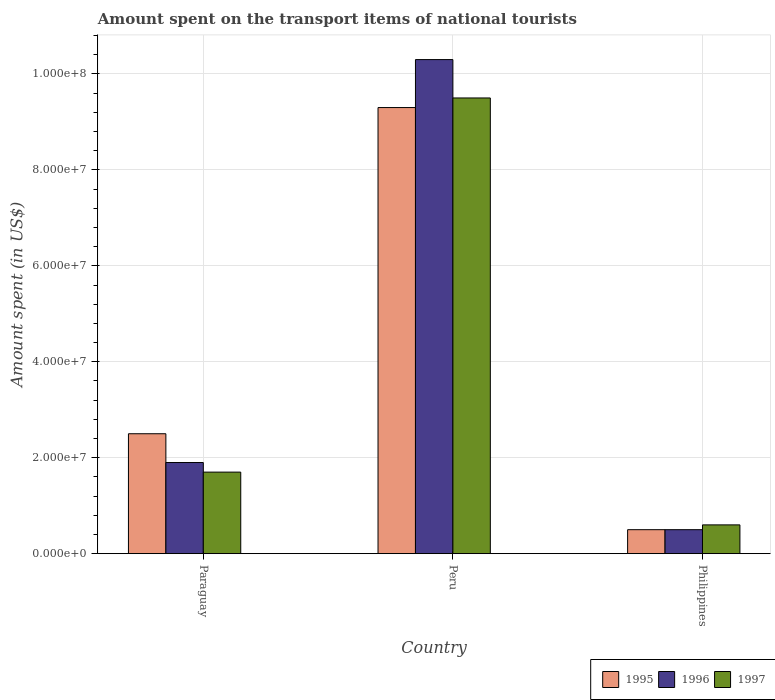Are the number of bars per tick equal to the number of legend labels?
Your answer should be compact. Yes. How many bars are there on the 1st tick from the right?
Keep it short and to the point. 3. What is the label of the 3rd group of bars from the left?
Your answer should be very brief. Philippines. What is the amount spent on the transport items of national tourists in 1995 in Peru?
Make the answer very short. 9.30e+07. Across all countries, what is the maximum amount spent on the transport items of national tourists in 1997?
Provide a succinct answer. 9.50e+07. Across all countries, what is the minimum amount spent on the transport items of national tourists in 1997?
Offer a terse response. 6.00e+06. In which country was the amount spent on the transport items of national tourists in 1997 maximum?
Offer a very short reply. Peru. What is the total amount spent on the transport items of national tourists in 1995 in the graph?
Provide a short and direct response. 1.23e+08. What is the difference between the amount spent on the transport items of national tourists in 1997 in Paraguay and that in Peru?
Keep it short and to the point. -7.80e+07. What is the difference between the amount spent on the transport items of national tourists in 1995 in Philippines and the amount spent on the transport items of national tourists in 1997 in Paraguay?
Your response must be concise. -1.20e+07. What is the average amount spent on the transport items of national tourists in 1996 per country?
Make the answer very short. 4.23e+07. In how many countries, is the amount spent on the transport items of national tourists in 1995 greater than 48000000 US$?
Offer a terse response. 1. What is the ratio of the amount spent on the transport items of national tourists in 1997 in Paraguay to that in Philippines?
Your answer should be very brief. 2.83. What is the difference between the highest and the second highest amount spent on the transport items of national tourists in 1995?
Your answer should be very brief. 8.80e+07. What is the difference between the highest and the lowest amount spent on the transport items of national tourists in 1997?
Make the answer very short. 8.90e+07. What does the 2nd bar from the left in Peru represents?
Keep it short and to the point. 1996. What does the 2nd bar from the right in Philippines represents?
Your response must be concise. 1996. Is it the case that in every country, the sum of the amount spent on the transport items of national tourists in 1997 and amount spent on the transport items of national tourists in 1996 is greater than the amount spent on the transport items of national tourists in 1995?
Offer a terse response. Yes. Are all the bars in the graph horizontal?
Ensure brevity in your answer.  No. What is the difference between two consecutive major ticks on the Y-axis?
Your answer should be very brief. 2.00e+07. Are the values on the major ticks of Y-axis written in scientific E-notation?
Keep it short and to the point. Yes. Does the graph contain any zero values?
Offer a terse response. No. Where does the legend appear in the graph?
Your response must be concise. Bottom right. How many legend labels are there?
Keep it short and to the point. 3. How are the legend labels stacked?
Your answer should be very brief. Horizontal. What is the title of the graph?
Keep it short and to the point. Amount spent on the transport items of national tourists. Does "1967" appear as one of the legend labels in the graph?
Keep it short and to the point. No. What is the label or title of the Y-axis?
Your answer should be very brief. Amount spent (in US$). What is the Amount spent (in US$) in 1995 in Paraguay?
Keep it short and to the point. 2.50e+07. What is the Amount spent (in US$) of 1996 in Paraguay?
Keep it short and to the point. 1.90e+07. What is the Amount spent (in US$) of 1997 in Paraguay?
Your answer should be very brief. 1.70e+07. What is the Amount spent (in US$) of 1995 in Peru?
Provide a succinct answer. 9.30e+07. What is the Amount spent (in US$) of 1996 in Peru?
Your answer should be compact. 1.03e+08. What is the Amount spent (in US$) in 1997 in Peru?
Your answer should be compact. 9.50e+07. What is the Amount spent (in US$) in 1995 in Philippines?
Keep it short and to the point. 5.00e+06. What is the Amount spent (in US$) of 1996 in Philippines?
Your answer should be very brief. 5.00e+06. What is the Amount spent (in US$) in 1997 in Philippines?
Ensure brevity in your answer.  6.00e+06. Across all countries, what is the maximum Amount spent (in US$) of 1995?
Your response must be concise. 9.30e+07. Across all countries, what is the maximum Amount spent (in US$) of 1996?
Your response must be concise. 1.03e+08. Across all countries, what is the maximum Amount spent (in US$) in 1997?
Your answer should be compact. 9.50e+07. What is the total Amount spent (in US$) in 1995 in the graph?
Keep it short and to the point. 1.23e+08. What is the total Amount spent (in US$) in 1996 in the graph?
Your response must be concise. 1.27e+08. What is the total Amount spent (in US$) in 1997 in the graph?
Your answer should be compact. 1.18e+08. What is the difference between the Amount spent (in US$) in 1995 in Paraguay and that in Peru?
Give a very brief answer. -6.80e+07. What is the difference between the Amount spent (in US$) of 1996 in Paraguay and that in Peru?
Your answer should be compact. -8.40e+07. What is the difference between the Amount spent (in US$) in 1997 in Paraguay and that in Peru?
Offer a very short reply. -7.80e+07. What is the difference between the Amount spent (in US$) in 1995 in Paraguay and that in Philippines?
Offer a terse response. 2.00e+07. What is the difference between the Amount spent (in US$) in 1996 in Paraguay and that in Philippines?
Offer a very short reply. 1.40e+07. What is the difference between the Amount spent (in US$) in 1997 in Paraguay and that in Philippines?
Your answer should be very brief. 1.10e+07. What is the difference between the Amount spent (in US$) of 1995 in Peru and that in Philippines?
Provide a short and direct response. 8.80e+07. What is the difference between the Amount spent (in US$) in 1996 in Peru and that in Philippines?
Provide a short and direct response. 9.80e+07. What is the difference between the Amount spent (in US$) in 1997 in Peru and that in Philippines?
Offer a terse response. 8.90e+07. What is the difference between the Amount spent (in US$) in 1995 in Paraguay and the Amount spent (in US$) in 1996 in Peru?
Your answer should be compact. -7.80e+07. What is the difference between the Amount spent (in US$) of 1995 in Paraguay and the Amount spent (in US$) of 1997 in Peru?
Your answer should be very brief. -7.00e+07. What is the difference between the Amount spent (in US$) in 1996 in Paraguay and the Amount spent (in US$) in 1997 in Peru?
Offer a very short reply. -7.60e+07. What is the difference between the Amount spent (in US$) of 1995 in Paraguay and the Amount spent (in US$) of 1996 in Philippines?
Offer a terse response. 2.00e+07. What is the difference between the Amount spent (in US$) of 1995 in Paraguay and the Amount spent (in US$) of 1997 in Philippines?
Give a very brief answer. 1.90e+07. What is the difference between the Amount spent (in US$) of 1996 in Paraguay and the Amount spent (in US$) of 1997 in Philippines?
Your answer should be compact. 1.30e+07. What is the difference between the Amount spent (in US$) of 1995 in Peru and the Amount spent (in US$) of 1996 in Philippines?
Keep it short and to the point. 8.80e+07. What is the difference between the Amount spent (in US$) in 1995 in Peru and the Amount spent (in US$) in 1997 in Philippines?
Make the answer very short. 8.70e+07. What is the difference between the Amount spent (in US$) of 1996 in Peru and the Amount spent (in US$) of 1997 in Philippines?
Offer a very short reply. 9.70e+07. What is the average Amount spent (in US$) in 1995 per country?
Offer a terse response. 4.10e+07. What is the average Amount spent (in US$) of 1996 per country?
Offer a terse response. 4.23e+07. What is the average Amount spent (in US$) of 1997 per country?
Offer a very short reply. 3.93e+07. What is the difference between the Amount spent (in US$) of 1995 and Amount spent (in US$) of 1996 in Paraguay?
Offer a very short reply. 6.00e+06. What is the difference between the Amount spent (in US$) in 1996 and Amount spent (in US$) in 1997 in Paraguay?
Your answer should be very brief. 2.00e+06. What is the difference between the Amount spent (in US$) in 1995 and Amount spent (in US$) in 1996 in Peru?
Provide a succinct answer. -1.00e+07. What is the difference between the Amount spent (in US$) of 1996 and Amount spent (in US$) of 1997 in Peru?
Your answer should be very brief. 8.00e+06. What is the difference between the Amount spent (in US$) of 1995 and Amount spent (in US$) of 1996 in Philippines?
Make the answer very short. 0. What is the difference between the Amount spent (in US$) in 1996 and Amount spent (in US$) in 1997 in Philippines?
Offer a very short reply. -1.00e+06. What is the ratio of the Amount spent (in US$) in 1995 in Paraguay to that in Peru?
Ensure brevity in your answer.  0.27. What is the ratio of the Amount spent (in US$) of 1996 in Paraguay to that in Peru?
Offer a terse response. 0.18. What is the ratio of the Amount spent (in US$) of 1997 in Paraguay to that in Peru?
Keep it short and to the point. 0.18. What is the ratio of the Amount spent (in US$) in 1995 in Paraguay to that in Philippines?
Your response must be concise. 5. What is the ratio of the Amount spent (in US$) in 1996 in Paraguay to that in Philippines?
Give a very brief answer. 3.8. What is the ratio of the Amount spent (in US$) in 1997 in Paraguay to that in Philippines?
Keep it short and to the point. 2.83. What is the ratio of the Amount spent (in US$) of 1995 in Peru to that in Philippines?
Your answer should be very brief. 18.6. What is the ratio of the Amount spent (in US$) in 1996 in Peru to that in Philippines?
Your answer should be compact. 20.6. What is the ratio of the Amount spent (in US$) in 1997 in Peru to that in Philippines?
Keep it short and to the point. 15.83. What is the difference between the highest and the second highest Amount spent (in US$) in 1995?
Offer a very short reply. 6.80e+07. What is the difference between the highest and the second highest Amount spent (in US$) of 1996?
Your answer should be compact. 8.40e+07. What is the difference between the highest and the second highest Amount spent (in US$) in 1997?
Your response must be concise. 7.80e+07. What is the difference between the highest and the lowest Amount spent (in US$) in 1995?
Keep it short and to the point. 8.80e+07. What is the difference between the highest and the lowest Amount spent (in US$) in 1996?
Make the answer very short. 9.80e+07. What is the difference between the highest and the lowest Amount spent (in US$) of 1997?
Make the answer very short. 8.90e+07. 